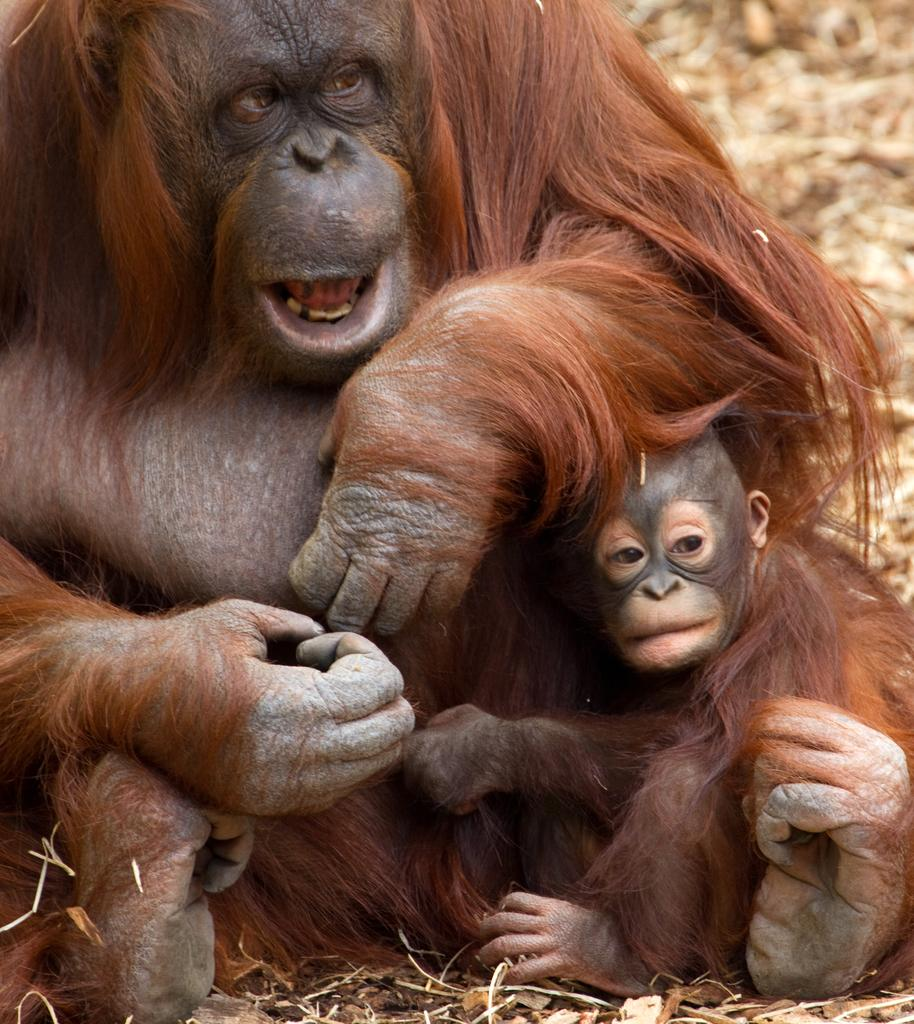What type of living organisms can be seen in the image? There are animals in the image. Where are the animals located in the image? The animals are on the ground. What degree of difficulty is the wave attempting in the image? There are no waves or wave-related activities present in the image. 